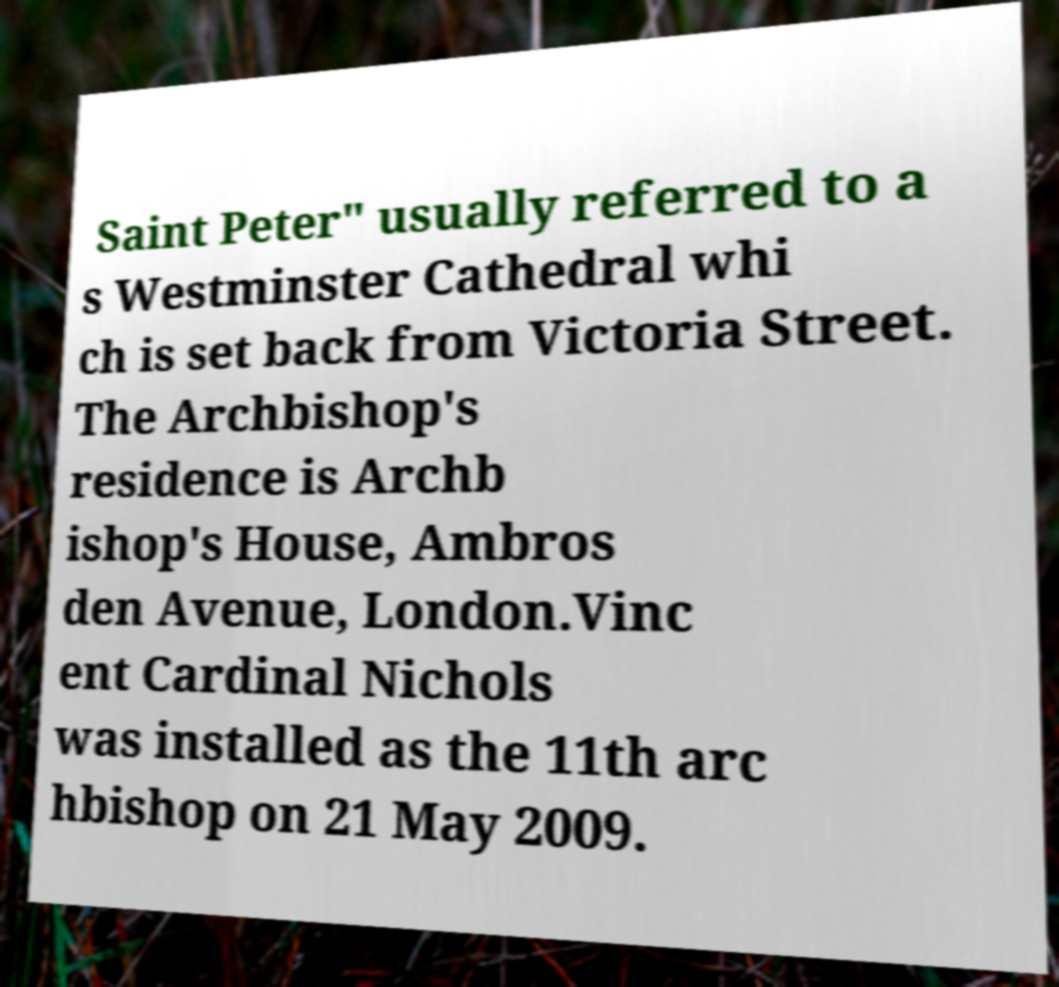Can you accurately transcribe the text from the provided image for me? Saint Peter" usually referred to a s Westminster Cathedral whi ch is set back from Victoria Street. The Archbishop's residence is Archb ishop's House, Ambros den Avenue, London.Vinc ent Cardinal Nichols was installed as the 11th arc hbishop on 21 May 2009. 